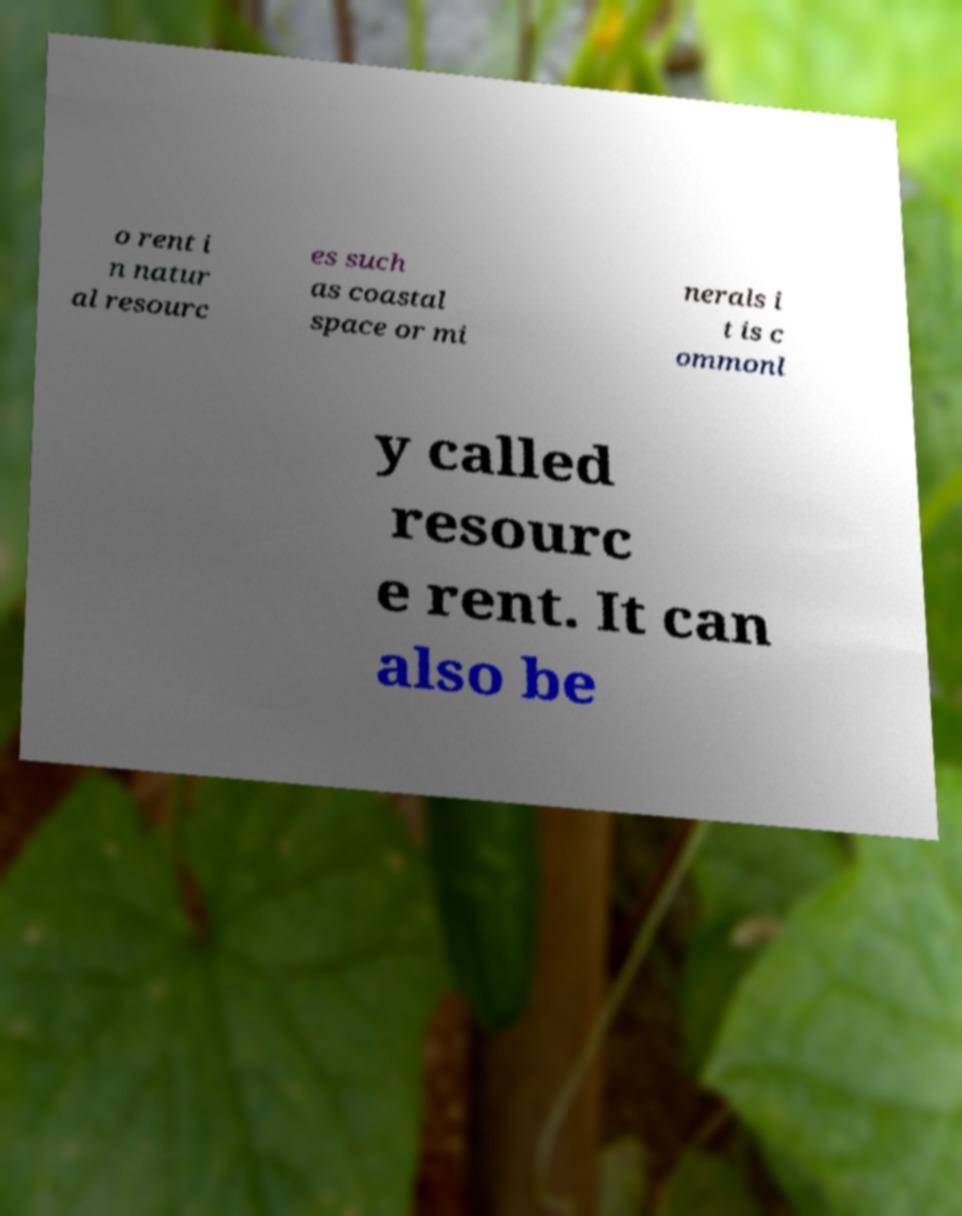Can you accurately transcribe the text from the provided image for me? o rent i n natur al resourc es such as coastal space or mi nerals i t is c ommonl y called resourc e rent. It can also be 